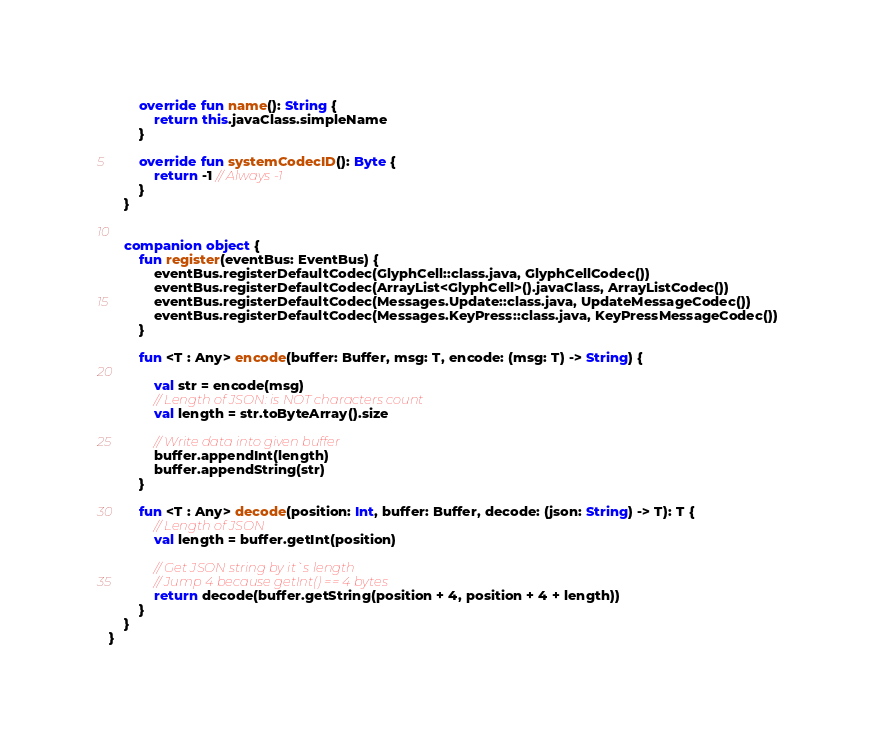<code> <loc_0><loc_0><loc_500><loc_500><_Kotlin_>
		override fun name(): String {
			return this.javaClass.simpleName
		}

		override fun systemCodecID(): Byte {
			return -1 // Always -1
		}
	}


	companion object {
		fun register(eventBus: EventBus) {
			eventBus.registerDefaultCodec(GlyphCell::class.java, GlyphCellCodec())
			eventBus.registerDefaultCodec(ArrayList<GlyphCell>().javaClass, ArrayListCodec())
			eventBus.registerDefaultCodec(Messages.Update::class.java, UpdateMessageCodec())
			eventBus.registerDefaultCodec(Messages.KeyPress::class.java, KeyPressMessageCodec())
		}

		fun <T : Any> encode(buffer: Buffer, msg: T, encode: (msg: T) -> String) {

			val str = encode(msg)
			// Length of JSON: is NOT characters count
			val length = str.toByteArray().size

			// Write data into given buffer
			buffer.appendInt(length)
			buffer.appendString(str)
		}

		fun <T : Any> decode(position: Int, buffer: Buffer, decode: (json: String) -> T): T {
			// Length of JSON
			val length = buffer.getInt(position)

			// Get JSON string by it`s length
			// Jump 4 because getInt() == 4 bytes
			return decode(buffer.getString(position + 4, position + 4 + length))
		}
	}
}</code> 